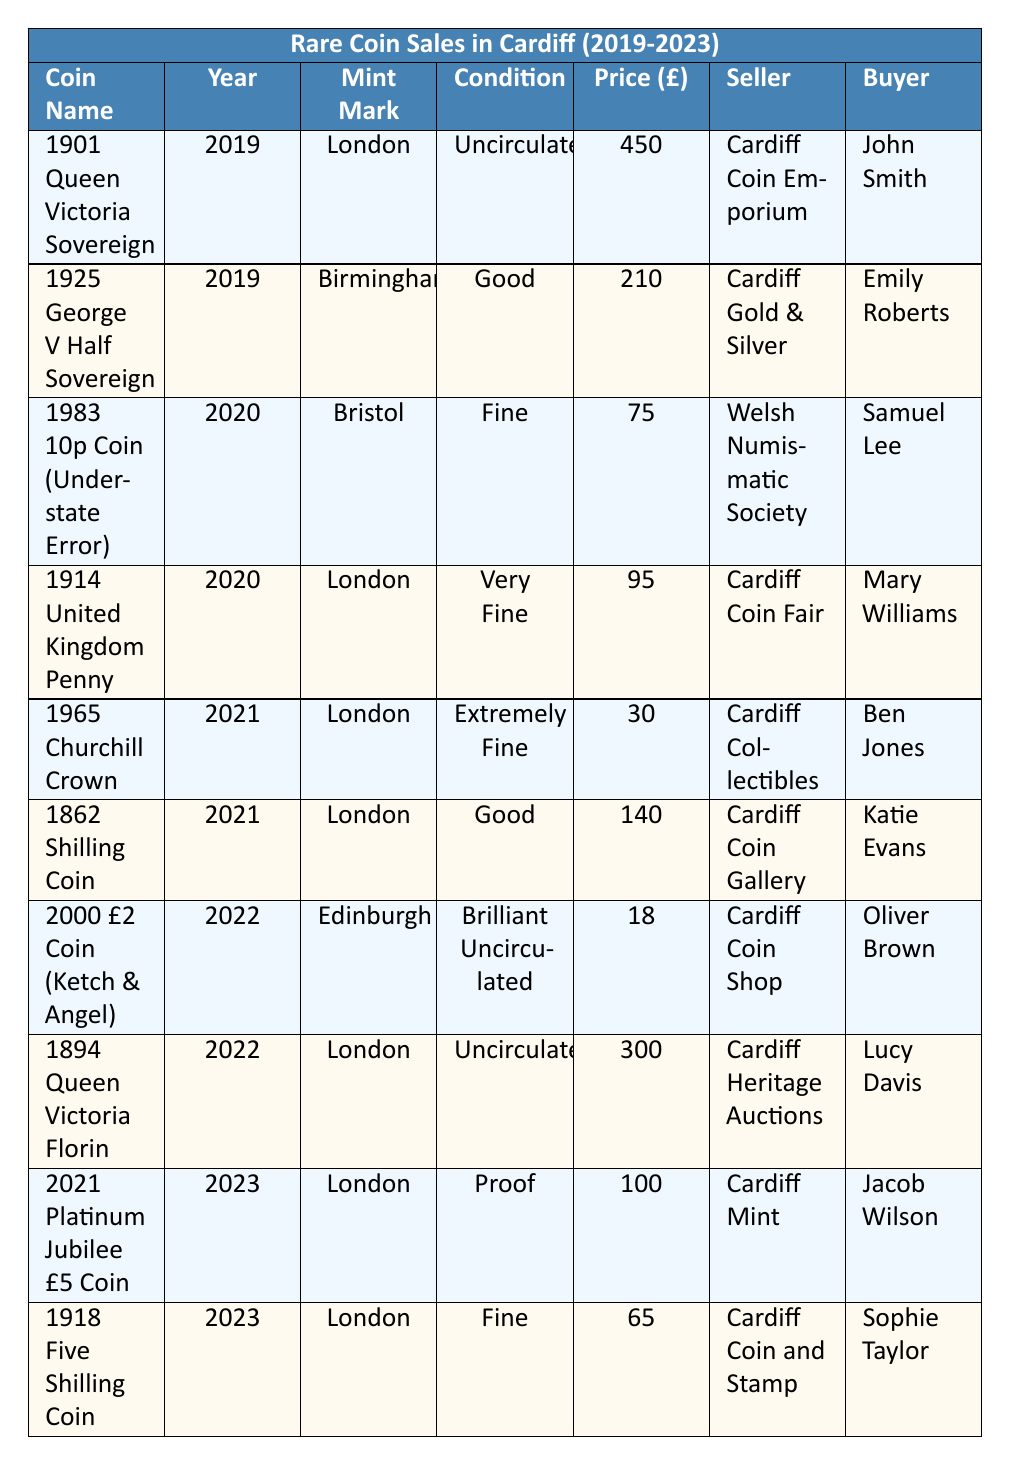What was the highest price paid for a coin sold in Cardiff over the last five years? The highest price in the "Price (£)" column is 450, corresponding to the "1901 Queen Victoria Sovereign" sold in 2019.
Answer: 450 How many coins were sold in 2020? From the table, there are two entries for the year 2020: "1983 10p Coin (Understate Error)" and "1914 United Kingdom Penny." Thus, the total count is 2.
Answer: 2 What condition was the "1925 George V Half Sovereign" in when it was sold? The "1925 George V Half Sovereign" is listed in the table under the "Condition" column as "Good."
Answer: Good Which seller sold the "1894 Queen Victoria Florin"? The seller for the "1894 Queen Victoria Florin," according to the table, is "Cardiff Heritage Auctions."
Answer: Cardiff Heritage Auctions What is the average price of coins sold in 2021? The prices of the coins sold in 2021 are 30 and 140. The average price is calculated as (30 + 140) / 2 = 85.
Answer: 85 Did any coins sell for less than £20? Reviewing the prices in the table, the lowest price listed is 18 from the "2000 £2 Coin (Ketch & Angel)," which is indeed less than £20.
Answer: Yes How many different sellers were involved in the sales over the five years? There are six unique sellers listed: Cardiff Coin Emporium, Cardiff Gold & Silver, Welsh Numismatic Society, Cardiff Coin Fair, Cardiff Collectibles, Cardiff Coin Gallery, Cardiff Coin Shop, Cardiff Heritage Auctions, Cardiff Mint, and Cardiff Coin and Stamp, totaling ten distinct sellers.
Answer: 10 Which year had the highest number of sales? 2019 and 2020 each had 2 sales, while 2021, 2022, and 2023 each had 2 sales as well. All years had the same number of sales, with no single year having more.
Answer: All years had equal sales What was the total value of all coins sold in Cardiff in 2022? From 2022, the prices are 18 and 300. Summing these gives 18 + 300 = 318.
Answer: 318 Is there a coin that was sold multiple times? Looking at the table data, each coin listed is unique to its sale and there are no duplicates for any coin names.
Answer: No 